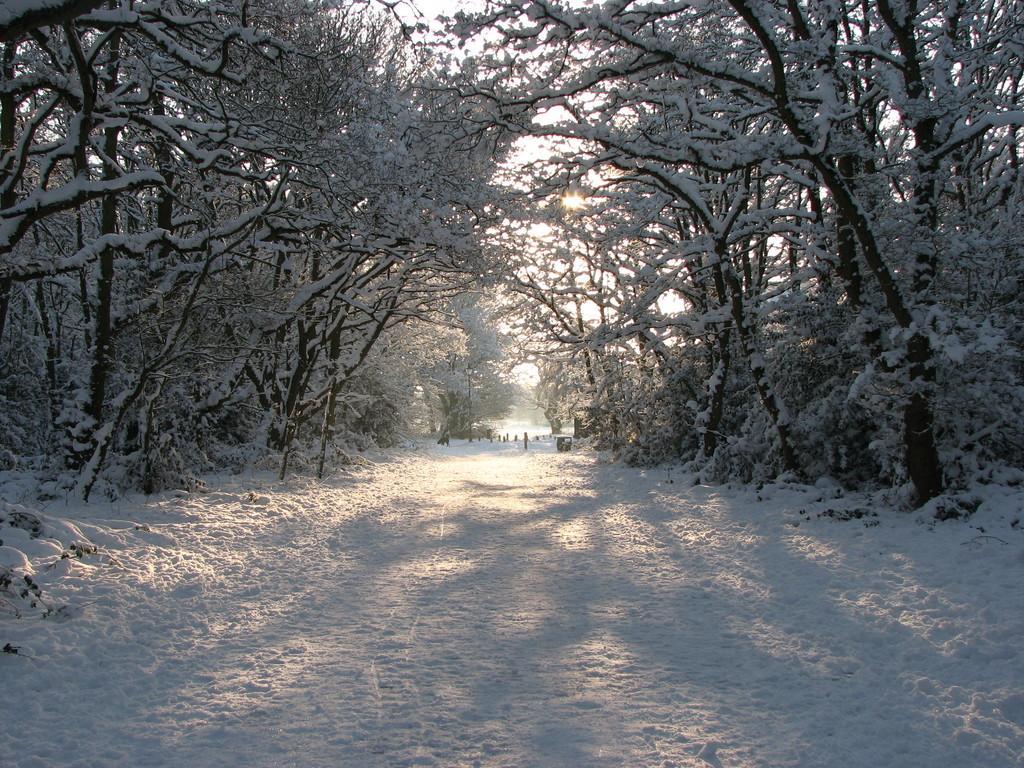Can you describe this image briefly? In this picture we can see the snow and trees. Behind the trees, it looks like the sky. 